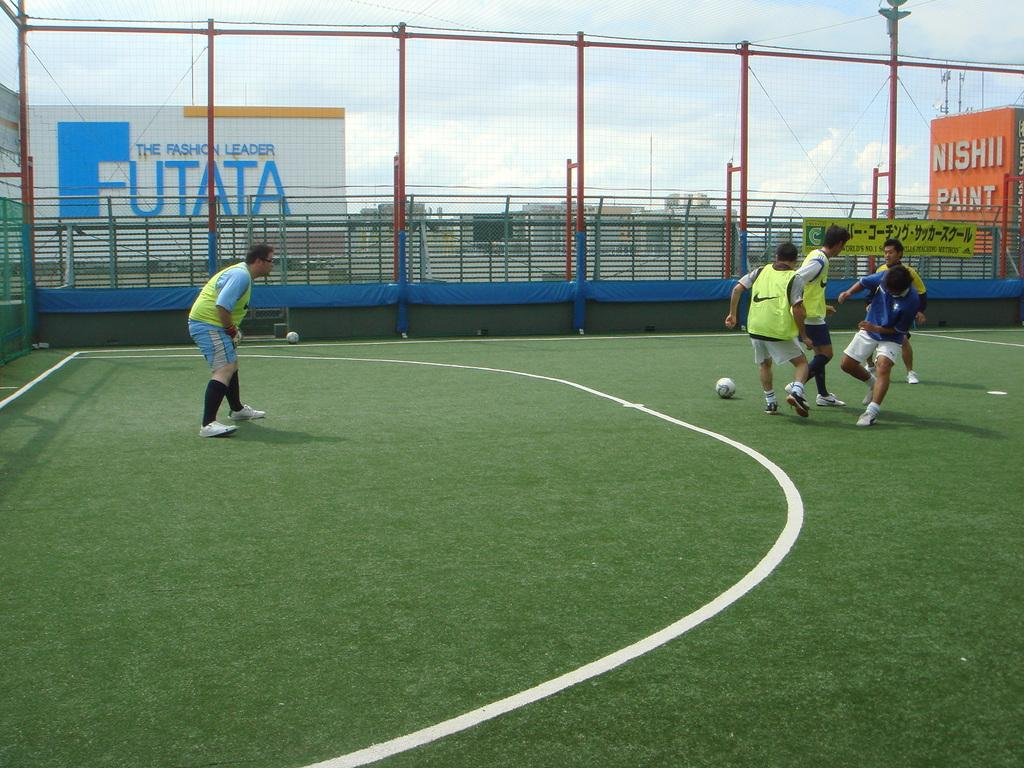<image>
Present a compact description of the photo's key features. Some men are playing soccer in a field infront of a sign for Futata. 